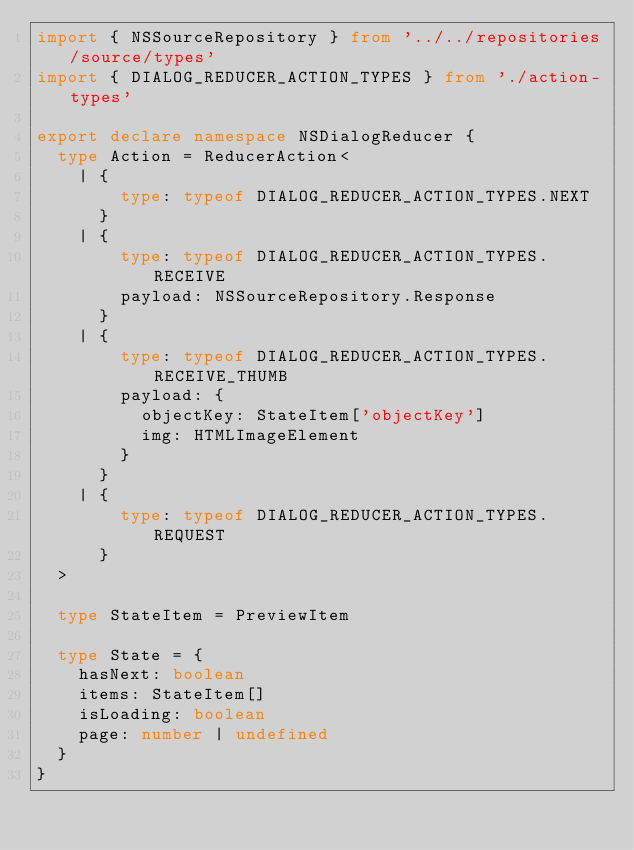<code> <loc_0><loc_0><loc_500><loc_500><_TypeScript_>import { NSSourceRepository } from '../../repositories/source/types'
import { DIALOG_REDUCER_ACTION_TYPES } from './action-types'

export declare namespace NSDialogReducer {
  type Action = ReducerAction<
    | {
        type: typeof DIALOG_REDUCER_ACTION_TYPES.NEXT
      }
    | {
        type: typeof DIALOG_REDUCER_ACTION_TYPES.RECEIVE
        payload: NSSourceRepository.Response
      }
    | {
        type: typeof DIALOG_REDUCER_ACTION_TYPES.RECEIVE_THUMB
        payload: {
          objectKey: StateItem['objectKey']
          img: HTMLImageElement
        }
      }
    | {
        type: typeof DIALOG_REDUCER_ACTION_TYPES.REQUEST
      }
  >

  type StateItem = PreviewItem

  type State = {
    hasNext: boolean
    items: StateItem[]
    isLoading: boolean
    page: number | undefined
  }
}
</code> 